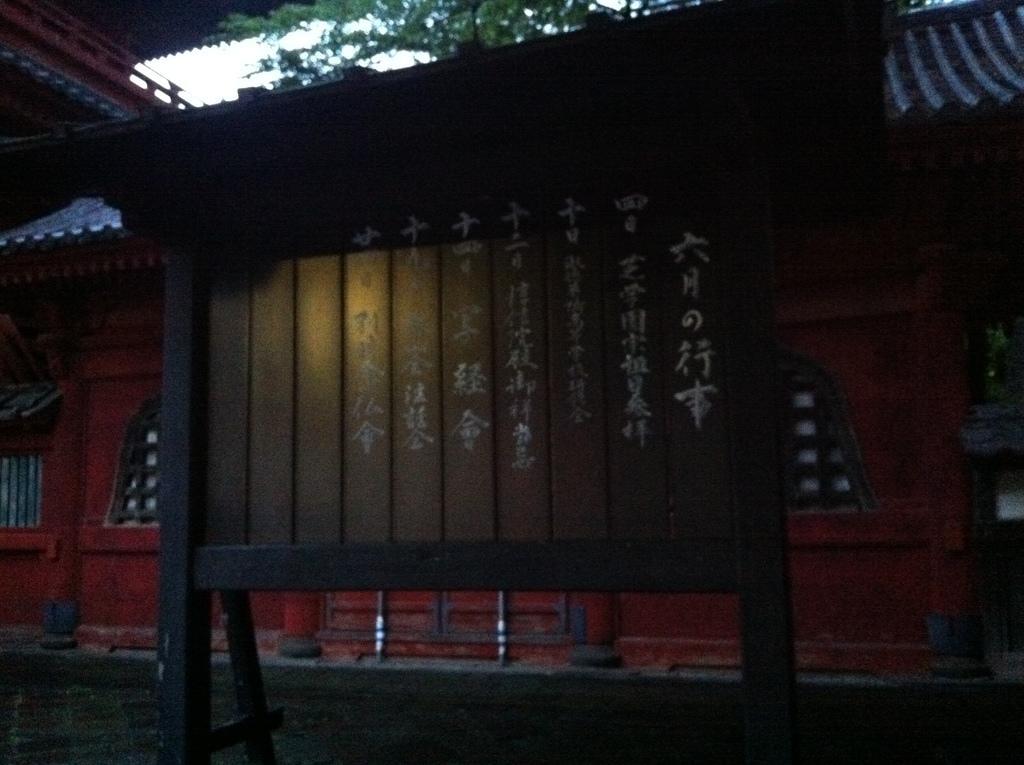How would you summarize this image in a sentence or two? In this image there are some letters written on the wooden board, and in the background there is a building, tree,sky. 